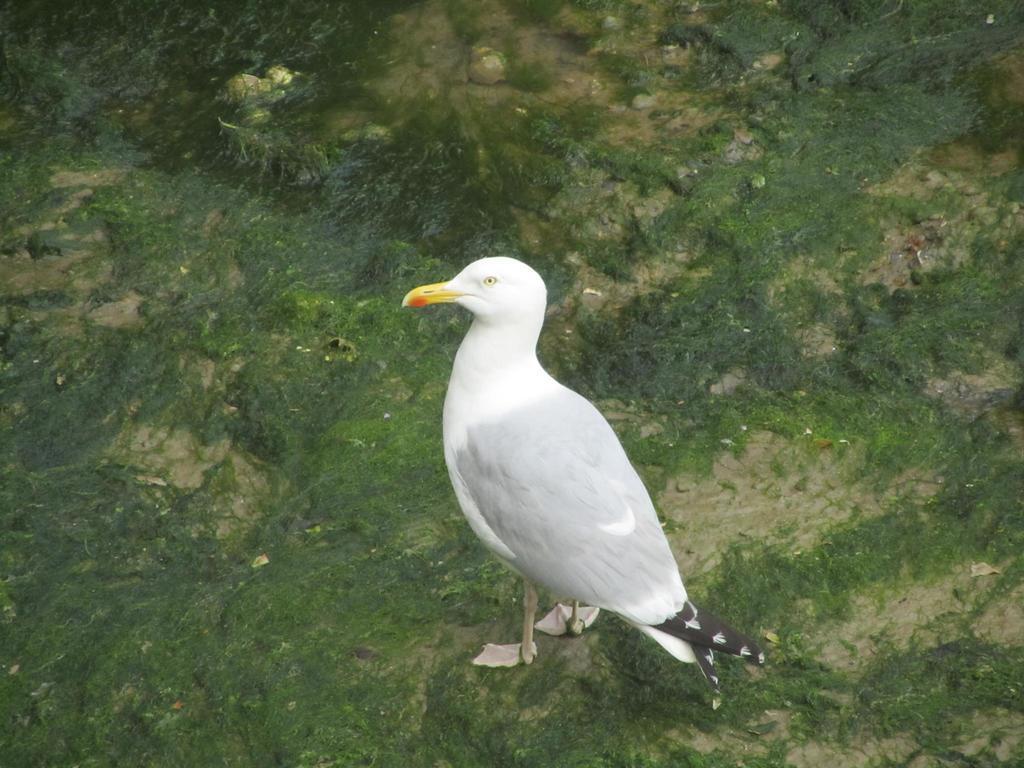Can you describe this image briefly? This image consists of a bird it is in white color. At the bottom, there is ground and we can see the green grass on the ground. 